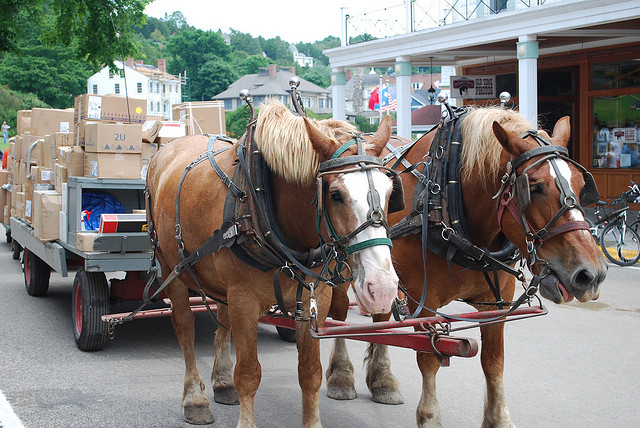Identify the text contained in this image. 2U 